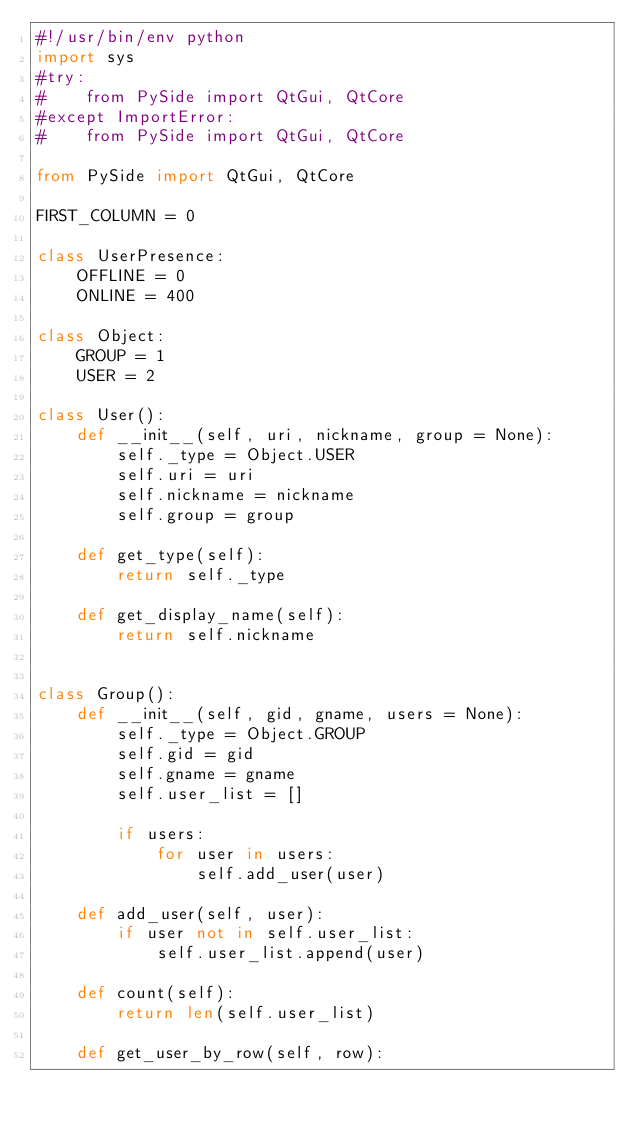<code> <loc_0><loc_0><loc_500><loc_500><_Python_>#!/usr/bin/env python
import sys
#try:
#    from PySide import QtGui, QtCore
#except ImportError:
#    from PySide import QtGui, QtCore

from PySide import QtGui, QtCore

FIRST_COLUMN = 0

class UserPresence:
    OFFLINE = 0
    ONLINE = 400

class Object:
    GROUP = 1
    USER = 2

class User():
    def __init__(self, uri, nickname, group = None):
        self._type = Object.USER
        self.uri = uri
        self.nickname = nickname
        self.group = group

    def get_type(self):
        return self._type

    def get_display_name(self):
        return self.nickname


class Group():
    def __init__(self, gid, gname, users = None):
        self._type = Object.GROUP
        self.gid = gid
        self.gname = gname
        self.user_list = []

        if users:
            for user in users:
                self.add_user(user)

    def add_user(self, user):
        if user not in self.user_list:
            self.user_list.append(user)

    def count(self):
        return len(self.user_list)

    def get_user_by_row(self, row):</code> 